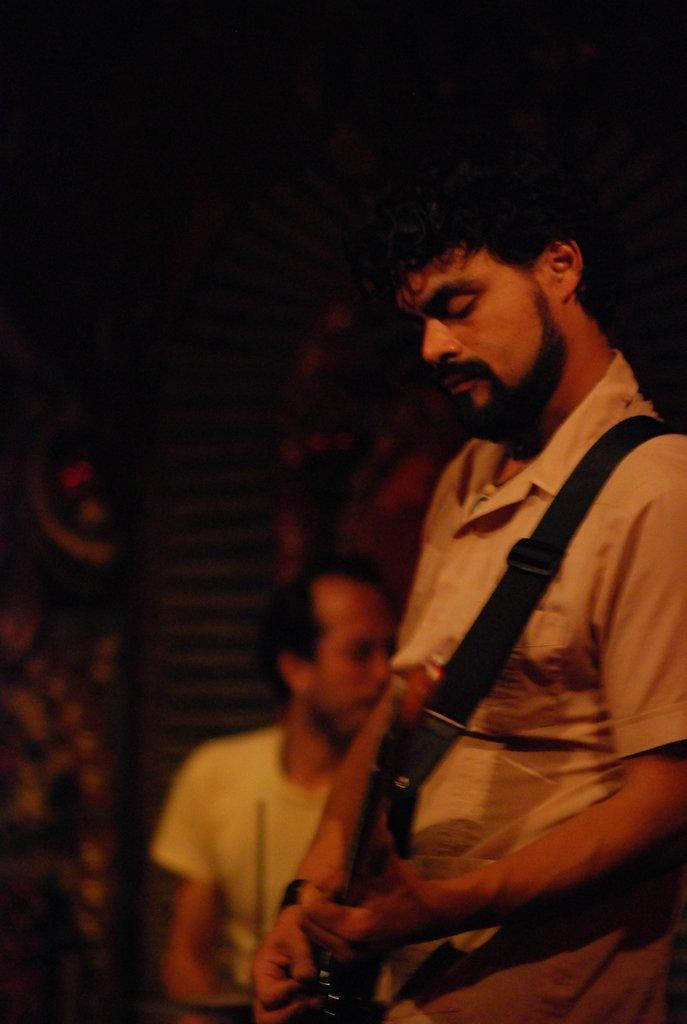In one or two sentences, can you explain what this image depicts? In the picture we can see a man holding a guitar, a man is with beard and white shirt, in the background we can see a person standing near the wall. On the wall we can also wear a carpet which is designed. 